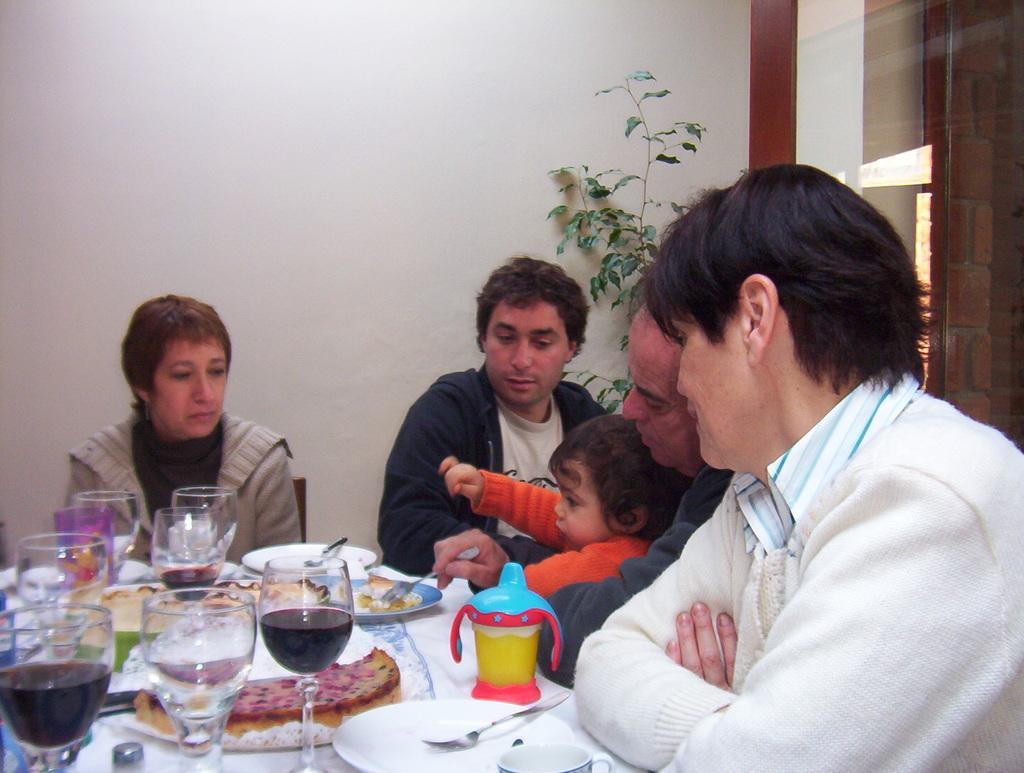Can you describe this image briefly? In this image, we can see a group of people wearing clothes and sitting in front of the table. This table contains glasses and plates. There is a plant in front of the wall. 